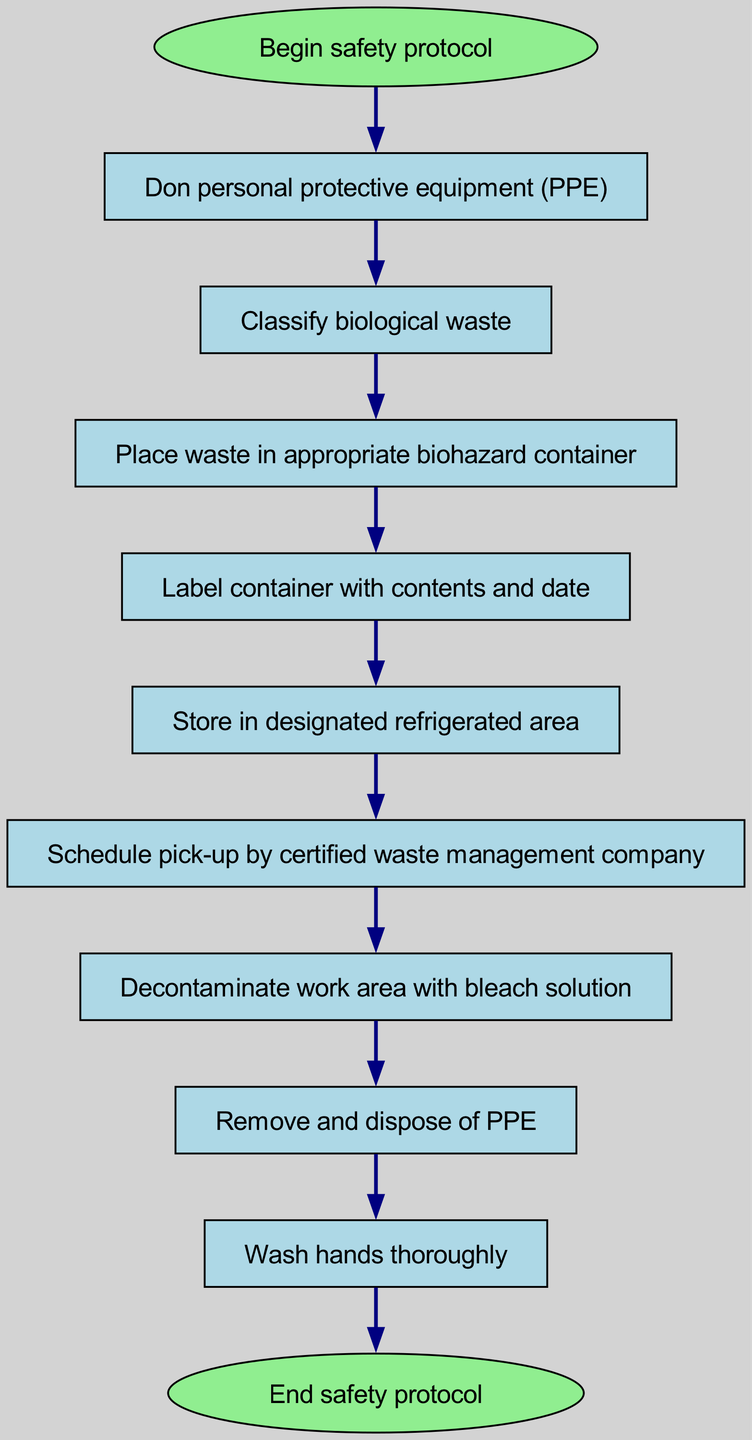What is the first step in the safety protocol? The first step, which is the starting point of the flow chart, is labeled "Begin safety protocol". Therefore, the answer reflects this initial action within the protocol.
Answer: Begin safety protocol How many total steps are in the protocol? By counting each individual node listed in the flow chart from start to end, we identify the total number of nodes, which are 10 in total.
Answer: 10 What should you do after donning personal protective equipment? According to the flow order, after "Don personal protective equipment", the next step is to "Classify biological waste". This reflects the immediate next action in the protocol.
Answer: Classify biological waste What type of container should the waste be placed in? The diagram specifies that biological waste should be placed in an "appropriate biohazard container", indicating the specific requirements for disposal.
Answer: Appropriate biohazard container What is the last action taken in the protocol? The flow chart outlines that the last step before completing the protocol is "Wash hands thoroughly", which is clearly stated as the penultimate action and leads to the end.
Answer: Wash hands thoroughly What process follows after labeling the container? Following the step of labeling the container with contents and date, the next action in the sequence is to "Store in designated refrigerated area". This illustrates the subsequent requirement for safe practice.
Answer: Store in designated refrigerated area How is the work area cleaned after handling biological waste? The diagram indicates that the work area should be "Decontaminated with bleach solution", providing a specific method for ensuring safety after waste handling.
Answer: Decontaminate with bleach solution What should be done with personal protective equipment after the protocol? At the end of the safety procedure, the flow chart indicates that one must "Remove and dispose of PPE", which details the disposal method for protective gear.
Answer: Remove and dispose of PPE What action is taken before scheduling waste pickup? According to the sequence in the flow chart, the action taken prior to scheduling pick-up by a certified waste management company is "Store in designated refrigerated area". This shows the necessary steps for proper handling.
Answer: Store in designated refrigerated area 